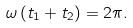Convert formula to latex. <formula><loc_0><loc_0><loc_500><loc_500>\omega \left ( t _ { 1 } + t _ { 2 } \right ) = 2 \pi .</formula> 